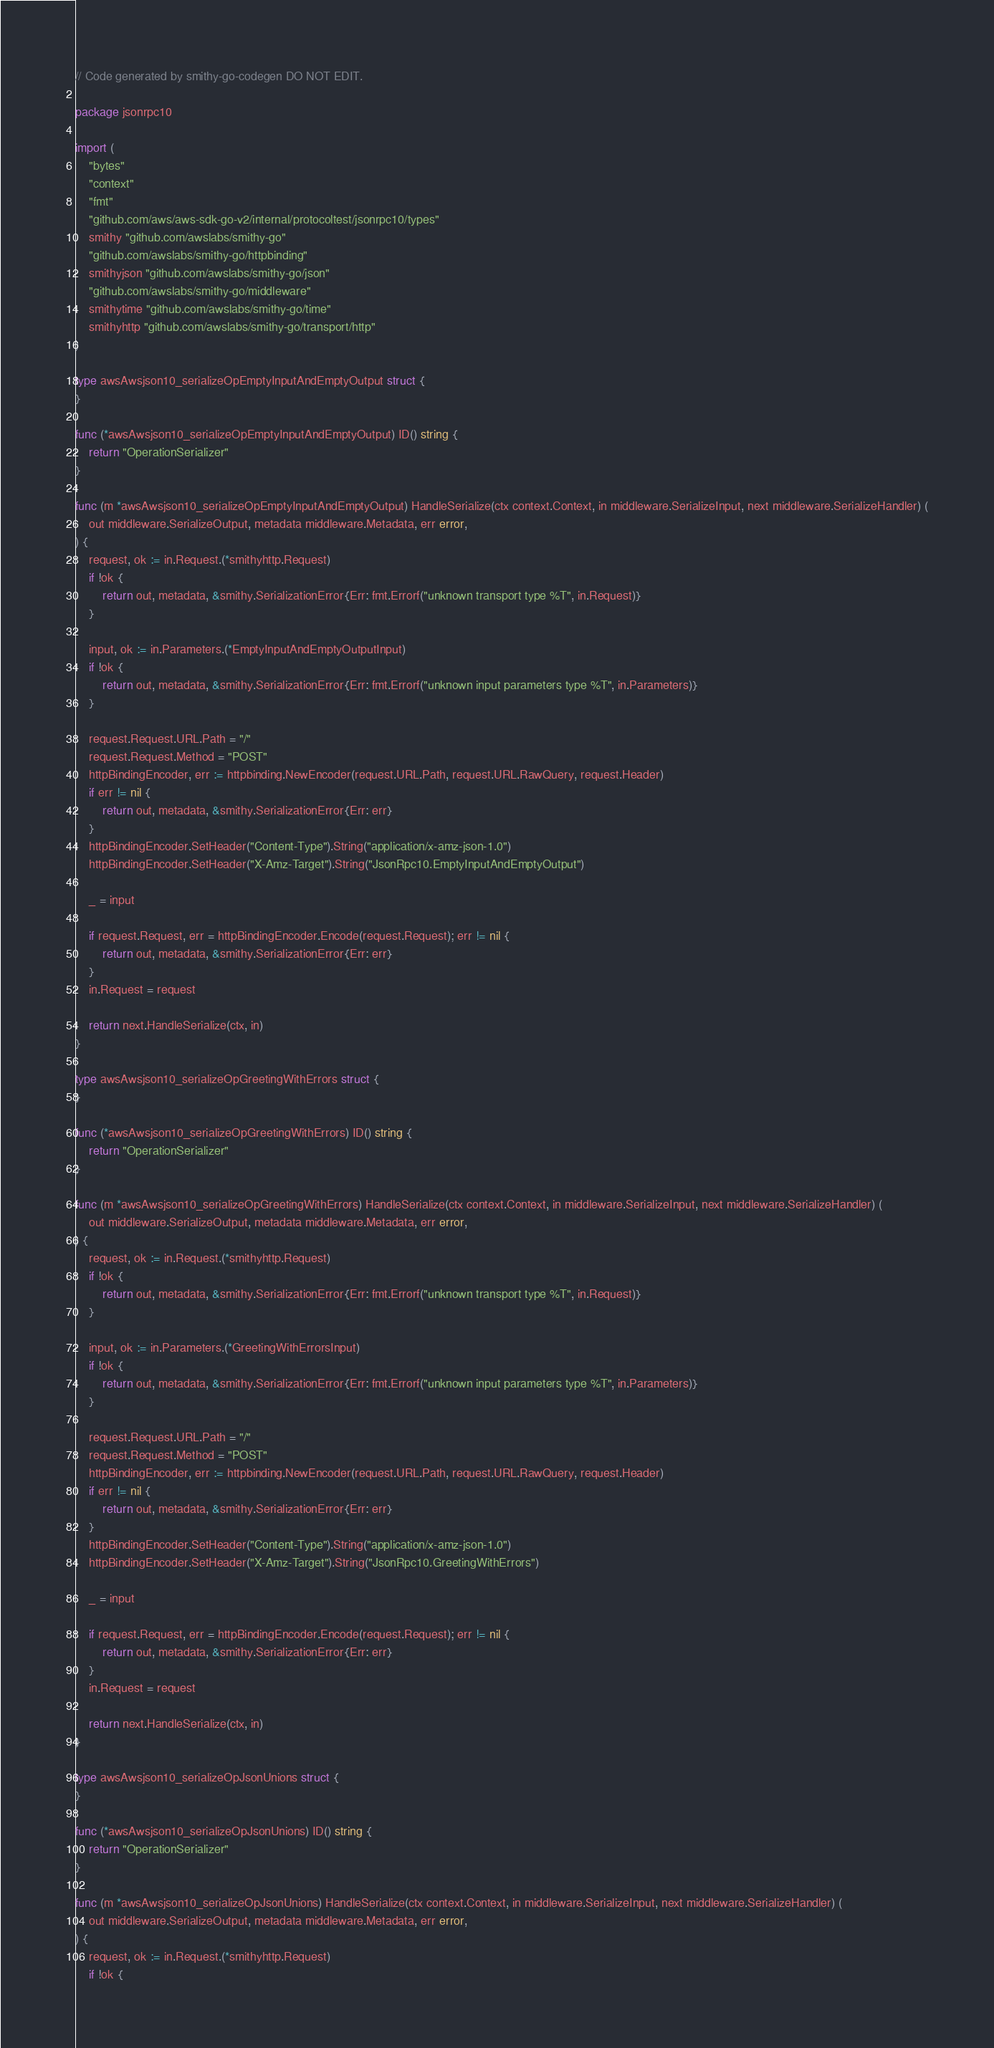Convert code to text. <code><loc_0><loc_0><loc_500><loc_500><_Go_>// Code generated by smithy-go-codegen DO NOT EDIT.

package jsonrpc10

import (
	"bytes"
	"context"
	"fmt"
	"github.com/aws/aws-sdk-go-v2/internal/protocoltest/jsonrpc10/types"
	smithy "github.com/awslabs/smithy-go"
	"github.com/awslabs/smithy-go/httpbinding"
	smithyjson "github.com/awslabs/smithy-go/json"
	"github.com/awslabs/smithy-go/middleware"
	smithytime "github.com/awslabs/smithy-go/time"
	smithyhttp "github.com/awslabs/smithy-go/transport/http"
)

type awsAwsjson10_serializeOpEmptyInputAndEmptyOutput struct {
}

func (*awsAwsjson10_serializeOpEmptyInputAndEmptyOutput) ID() string {
	return "OperationSerializer"
}

func (m *awsAwsjson10_serializeOpEmptyInputAndEmptyOutput) HandleSerialize(ctx context.Context, in middleware.SerializeInput, next middleware.SerializeHandler) (
	out middleware.SerializeOutput, metadata middleware.Metadata, err error,
) {
	request, ok := in.Request.(*smithyhttp.Request)
	if !ok {
		return out, metadata, &smithy.SerializationError{Err: fmt.Errorf("unknown transport type %T", in.Request)}
	}

	input, ok := in.Parameters.(*EmptyInputAndEmptyOutputInput)
	if !ok {
		return out, metadata, &smithy.SerializationError{Err: fmt.Errorf("unknown input parameters type %T", in.Parameters)}
	}

	request.Request.URL.Path = "/"
	request.Request.Method = "POST"
	httpBindingEncoder, err := httpbinding.NewEncoder(request.URL.Path, request.URL.RawQuery, request.Header)
	if err != nil {
		return out, metadata, &smithy.SerializationError{Err: err}
	}
	httpBindingEncoder.SetHeader("Content-Type").String("application/x-amz-json-1.0")
	httpBindingEncoder.SetHeader("X-Amz-Target").String("JsonRpc10.EmptyInputAndEmptyOutput")

	_ = input

	if request.Request, err = httpBindingEncoder.Encode(request.Request); err != nil {
		return out, metadata, &smithy.SerializationError{Err: err}
	}
	in.Request = request

	return next.HandleSerialize(ctx, in)
}

type awsAwsjson10_serializeOpGreetingWithErrors struct {
}

func (*awsAwsjson10_serializeOpGreetingWithErrors) ID() string {
	return "OperationSerializer"
}

func (m *awsAwsjson10_serializeOpGreetingWithErrors) HandleSerialize(ctx context.Context, in middleware.SerializeInput, next middleware.SerializeHandler) (
	out middleware.SerializeOutput, metadata middleware.Metadata, err error,
) {
	request, ok := in.Request.(*smithyhttp.Request)
	if !ok {
		return out, metadata, &smithy.SerializationError{Err: fmt.Errorf("unknown transport type %T", in.Request)}
	}

	input, ok := in.Parameters.(*GreetingWithErrorsInput)
	if !ok {
		return out, metadata, &smithy.SerializationError{Err: fmt.Errorf("unknown input parameters type %T", in.Parameters)}
	}

	request.Request.URL.Path = "/"
	request.Request.Method = "POST"
	httpBindingEncoder, err := httpbinding.NewEncoder(request.URL.Path, request.URL.RawQuery, request.Header)
	if err != nil {
		return out, metadata, &smithy.SerializationError{Err: err}
	}
	httpBindingEncoder.SetHeader("Content-Type").String("application/x-amz-json-1.0")
	httpBindingEncoder.SetHeader("X-Amz-Target").String("JsonRpc10.GreetingWithErrors")

	_ = input

	if request.Request, err = httpBindingEncoder.Encode(request.Request); err != nil {
		return out, metadata, &smithy.SerializationError{Err: err}
	}
	in.Request = request

	return next.HandleSerialize(ctx, in)
}

type awsAwsjson10_serializeOpJsonUnions struct {
}

func (*awsAwsjson10_serializeOpJsonUnions) ID() string {
	return "OperationSerializer"
}

func (m *awsAwsjson10_serializeOpJsonUnions) HandleSerialize(ctx context.Context, in middleware.SerializeInput, next middleware.SerializeHandler) (
	out middleware.SerializeOutput, metadata middleware.Metadata, err error,
) {
	request, ok := in.Request.(*smithyhttp.Request)
	if !ok {</code> 